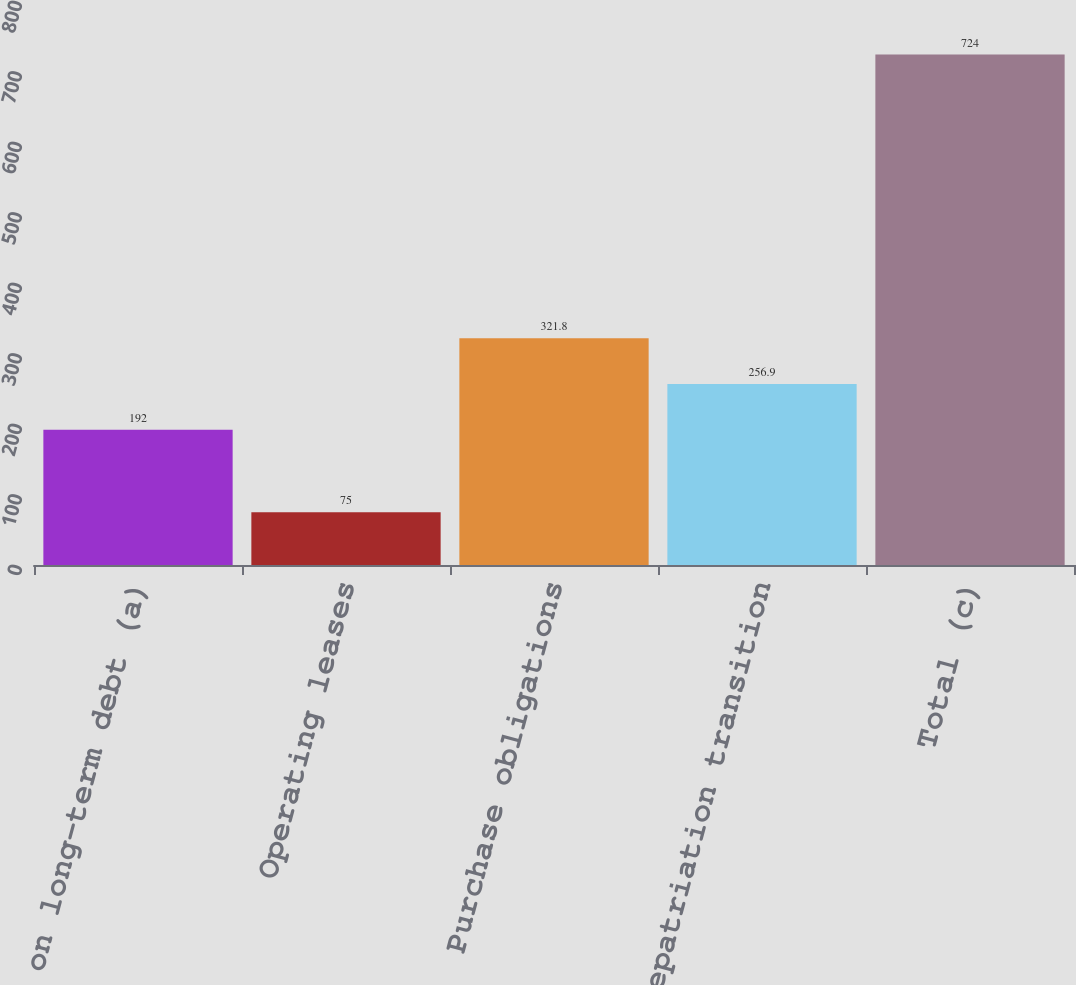Convert chart to OTSL. <chart><loc_0><loc_0><loc_500><loc_500><bar_chart><fcel>Interest on long-term debt (a)<fcel>Operating leases<fcel>Purchase obligations<fcel>Deemed repatriation transition<fcel>Total (c)<nl><fcel>192<fcel>75<fcel>321.8<fcel>256.9<fcel>724<nl></chart> 